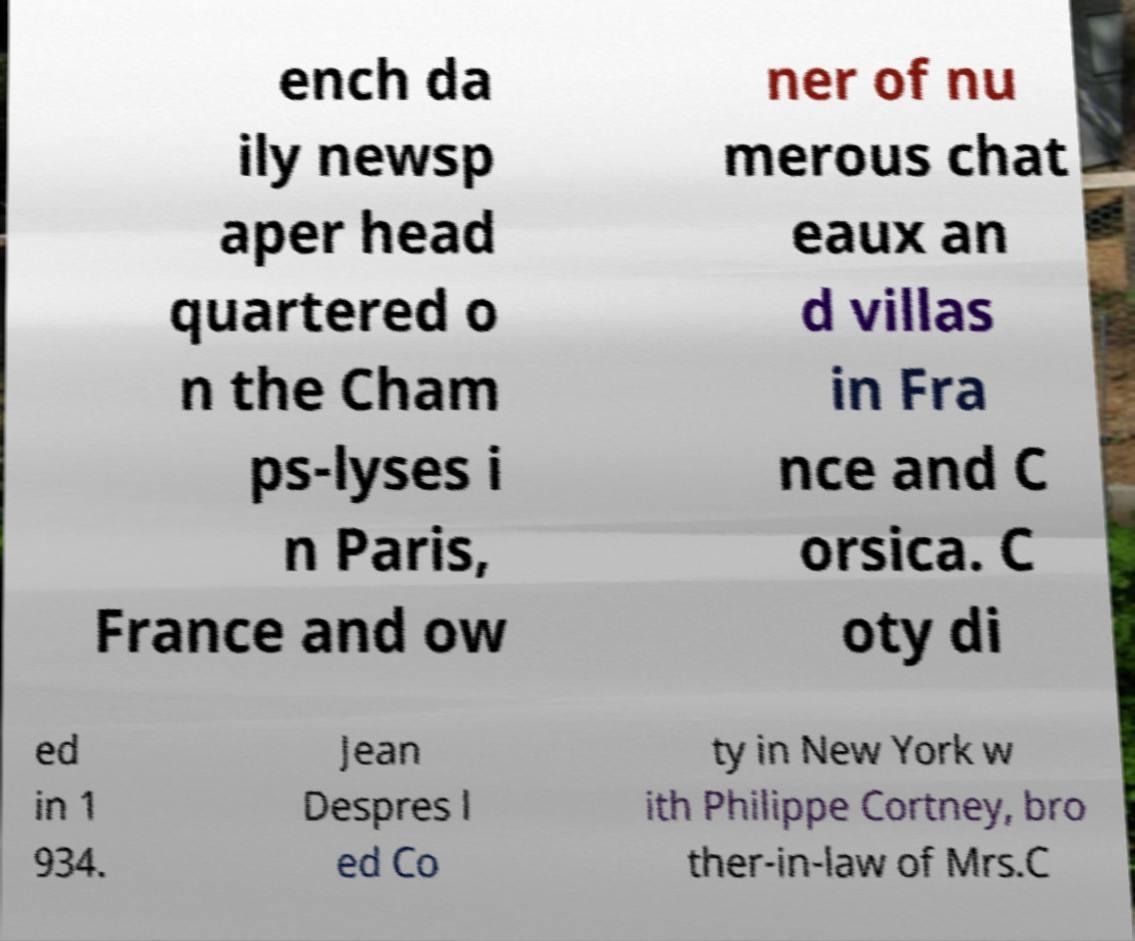Can you accurately transcribe the text from the provided image for me? ench da ily newsp aper head quartered o n the Cham ps-lyses i n Paris, France and ow ner of nu merous chat eaux an d villas in Fra nce and C orsica. C oty di ed in 1 934. Jean Despres l ed Co ty in New York w ith Philippe Cortney, bro ther-in-law of Mrs.C 